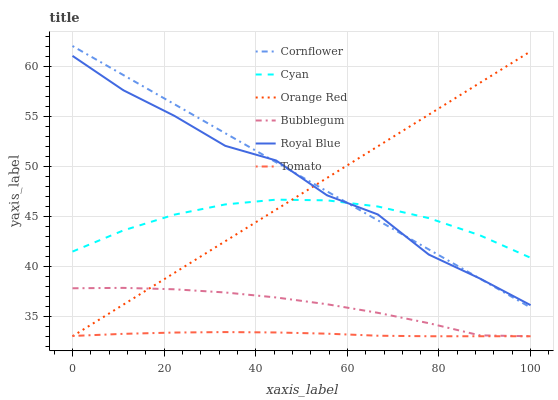Does Tomato have the minimum area under the curve?
Answer yes or no. Yes. Does Cornflower have the maximum area under the curve?
Answer yes or no. Yes. Does Bubblegum have the minimum area under the curve?
Answer yes or no. No. Does Bubblegum have the maximum area under the curve?
Answer yes or no. No. Is Cornflower the smoothest?
Answer yes or no. Yes. Is Royal Blue the roughest?
Answer yes or no. Yes. Is Bubblegum the smoothest?
Answer yes or no. No. Is Bubblegum the roughest?
Answer yes or no. No. Does Tomato have the lowest value?
Answer yes or no. Yes. Does Cornflower have the lowest value?
Answer yes or no. No. Does Cornflower have the highest value?
Answer yes or no. Yes. Does Bubblegum have the highest value?
Answer yes or no. No. Is Bubblegum less than Royal Blue?
Answer yes or no. Yes. Is Royal Blue greater than Bubblegum?
Answer yes or no. Yes. Does Cornflower intersect Royal Blue?
Answer yes or no. Yes. Is Cornflower less than Royal Blue?
Answer yes or no. No. Is Cornflower greater than Royal Blue?
Answer yes or no. No. Does Bubblegum intersect Royal Blue?
Answer yes or no. No. 